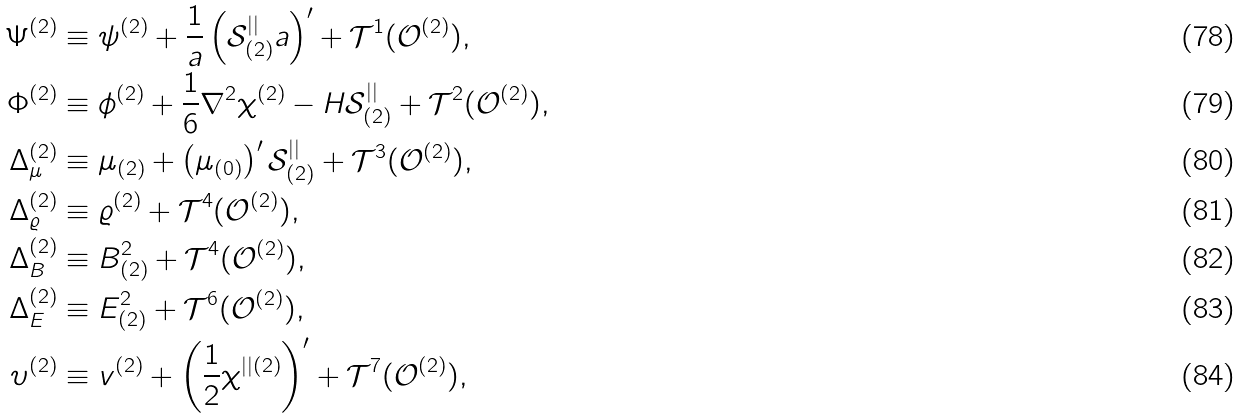Convert formula to latex. <formula><loc_0><loc_0><loc_500><loc_500>\Psi ^ { ( 2 ) } & \equiv \psi ^ { ( 2 ) } + \frac { 1 } { a } \left ( \mathcal { S } _ { ( 2 ) } ^ { | | } a \right ) ^ { \prime } + \mathcal { T } ^ { 1 } ( \mathcal { O } ^ { ( 2 ) } ) , \\ \Phi ^ { ( 2 ) } & \equiv \phi ^ { ( 2 ) } + \frac { 1 } { 6 } \nabla ^ { 2 } \chi ^ { ( 2 ) } - H \mathcal { S } _ { ( 2 ) } ^ { | | } + \mathcal { T } ^ { 2 } ( \mathcal { O } ^ { ( 2 ) } ) , \\ \Delta _ { \mu } ^ { ( 2 ) } & \equiv \mu _ { ( 2 ) } + \left ( \mu _ { ( 0 ) } \right ) ^ { \prime } \mathcal { S } _ { ( 2 ) } ^ { | | } + \mathcal { T } ^ { 3 } ( \mathcal { O } ^ { ( 2 ) } ) , \\ \Delta _ { \varrho } ^ { ( 2 ) } & \equiv \varrho ^ { ( 2 ) } + \mathcal { T } ^ { 4 } ( \mathcal { O } ^ { ( 2 ) } ) , \\ \Delta _ { B } ^ { ( 2 ) } & \equiv B ^ { 2 } _ { ( 2 ) } + \mathcal { T } ^ { 4 } ( \mathcal { O } ^ { ( 2 ) } ) , \\ \Delta _ { E } ^ { ( 2 ) } & \equiv E ^ { 2 } _ { ( 2 ) } + \mathcal { T } ^ { 6 } ( \mathcal { O } ^ { ( 2 ) } ) , \\ \upsilon ^ { ( 2 ) } & \equiv v ^ { ( 2 ) } + \left ( \frac { 1 } { 2 } \chi ^ { | | ( 2 ) } \right ) ^ { \prime } + \mathcal { T } ^ { 7 } ( \mathcal { O } ^ { ( 2 ) } ) ,</formula> 